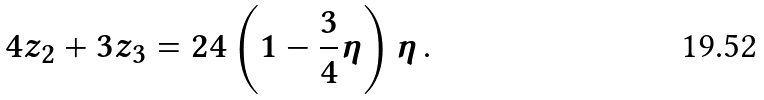<formula> <loc_0><loc_0><loc_500><loc_500>4 z _ { 2 } + 3 z _ { 3 } = 2 4 \left ( 1 - \frac { 3 } { 4 } \eta \right ) \eta \, .</formula> 